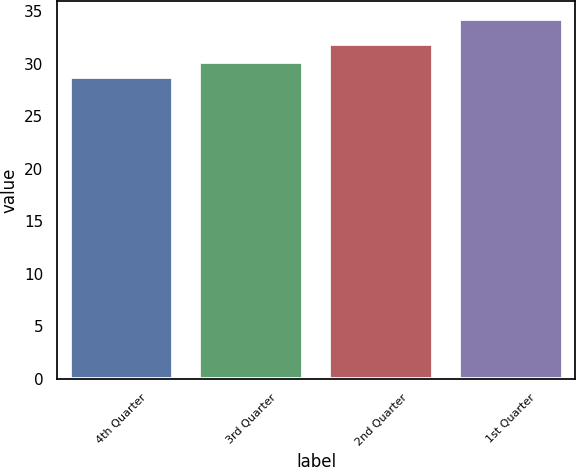Convert chart to OTSL. <chart><loc_0><loc_0><loc_500><loc_500><bar_chart><fcel>4th Quarter<fcel>3rd Quarter<fcel>2nd Quarter<fcel>1st Quarter<nl><fcel>28.74<fcel>30.16<fcel>31.83<fcel>34.26<nl></chart> 